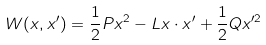<formula> <loc_0><loc_0><loc_500><loc_500>W ( x , x ^ { \prime } ) = \frac { 1 } { 2 } P x ^ { 2 } - L x \cdot x ^ { \prime } + \frac { 1 } { 2 } Q x ^ { \prime 2 }</formula> 